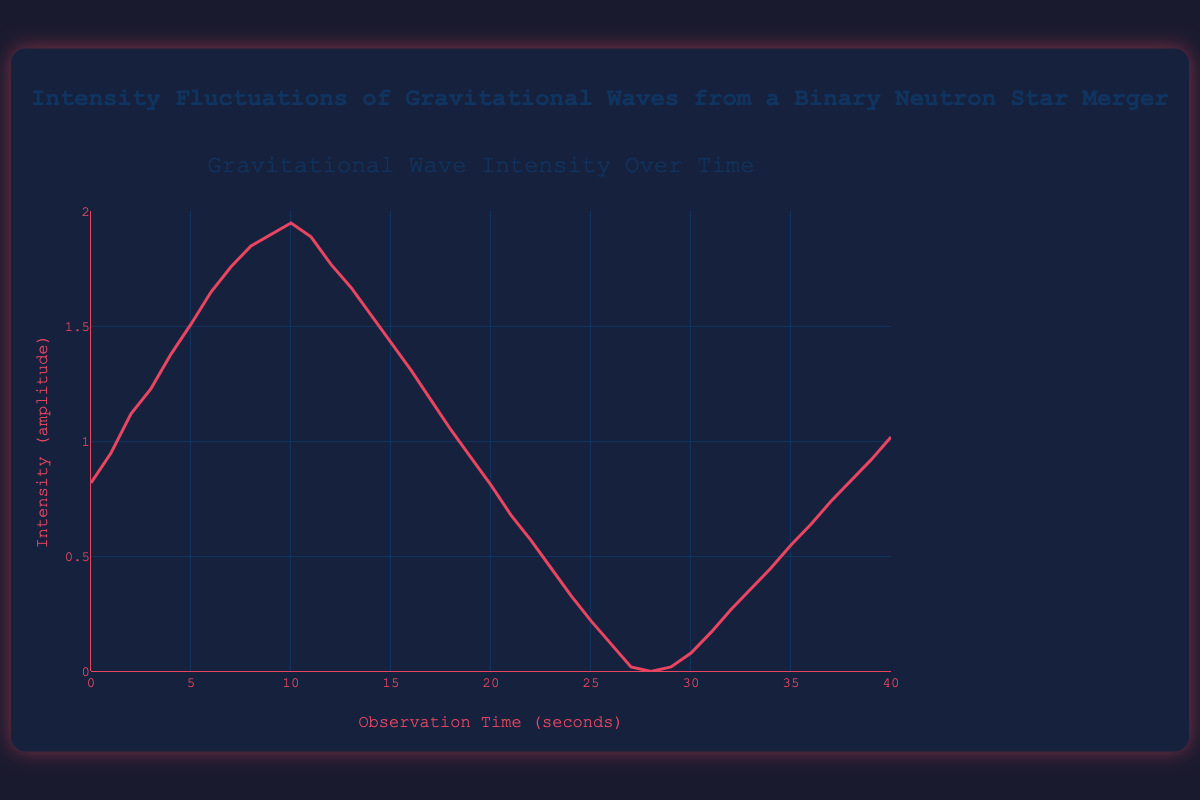How does the intensity change from the start to the end of the observation time? At the start (time = 0 seconds), the intensity is 0.82, and at the end (time = 40 seconds), the intensity is 1.02. Thus, the intensity increases by a difference of 0.2 over the observation period.
Answer: The intensity increases by 0.2 What is the highest intensity observed, and at what time? The plot shows the highest intensity at time = 10 seconds, where the intensity reaches 1.95.
Answer: The highest intensity is 1.95 at 10 seconds During which time interval does the intensity drop most sharply? To identify the sharpest drop, observe where the steepest negative slope occurs. The plot shows the sharpest drop between 10 seconds and 20 seconds, where the intensity decreases from 1.95 to 0.81, a drop of 1.14.
Answer: The drop is sharpest between 10 to 20 seconds What is the average intensity over the first 10 seconds? Sum the intensities at each second for the first 10 seconds and divide by 11 data points: (0.82 + 0.95 + 1.12 + 1.23 + 1.38 + 1.51 + 1.65 + 1.76 + 1.85 + 1.90 + 1.95) / 11 = 1.347.
Answer: 1.35 (rounded) How does the color and style of the line help in observing the data points? The line color, red, helps make the data stand out against the dark background. The line's width and continuous nature make it easier to follow trends over time.
Answer: Red line helps in observing trends Comparing the intensities at 5 seconds and 35 seconds, which is higher and by how much? At 5 seconds, the intensity is 1.51, and at 35 seconds, it is 0.55. The intensity at 5 seconds is higher by a difference of 0.96.
Answer: 1.51 is higher by 0.96 What pattern is observed in the intensity fluctuations after the initial intensity fall? After the initial rise and subsequent sharp fall up to 20 seconds, there are smaller oscillations, indicating a partial recovery in intensity.
Answer: Oscillations around lower intensity How many peaks and troughs are observed in the plot? Peaks occur at time points where the intensity changes from increasing to decreasing, and troughs happen where it changes from decreasing to increasing. There is 1 main peak at 10 seconds and 2 smaller peaks around 30 and 40 seconds, with 2 troughs around 20 and 28 seconds.
Answer: 3 peaks, 2 troughs At what interval does the intensity return to zero or nearly zero after the initial rise? The intensity first becomes nearly zero around 28 seconds, and it touches almost zero at 0 and 20 seconds too.
Answer: Around 28 seconds What is the range of observation time during which the intensity stays above 1? The intensity stays above 1 from about 2 seconds to 17 seconds, based on the graph.
Answer: From 2 to 17 seconds 